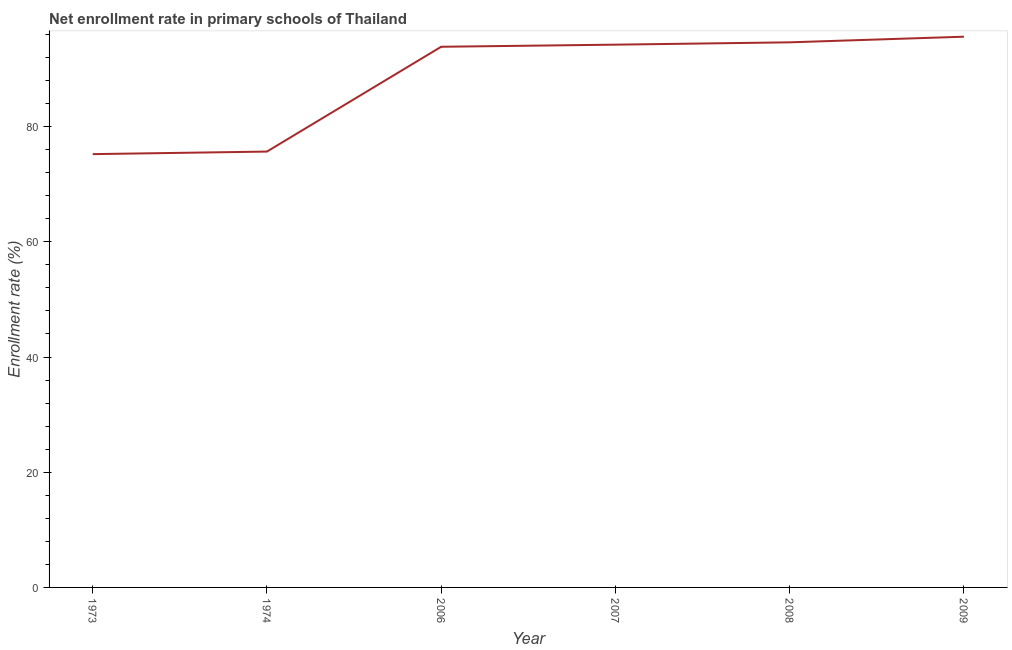What is the net enrollment rate in primary schools in 2009?
Provide a short and direct response. 95.61. Across all years, what is the maximum net enrollment rate in primary schools?
Give a very brief answer. 95.61. Across all years, what is the minimum net enrollment rate in primary schools?
Your answer should be very brief. 75.22. In which year was the net enrollment rate in primary schools minimum?
Your answer should be very brief. 1973. What is the sum of the net enrollment rate in primary schools?
Offer a very short reply. 529.22. What is the difference between the net enrollment rate in primary schools in 1974 and 2008?
Provide a succinct answer. -18.97. What is the average net enrollment rate in primary schools per year?
Your response must be concise. 88.2. What is the median net enrollment rate in primary schools?
Your response must be concise. 94.04. What is the ratio of the net enrollment rate in primary schools in 1973 to that in 2006?
Give a very brief answer. 0.8. What is the difference between the highest and the second highest net enrollment rate in primary schools?
Your response must be concise. 0.98. Is the sum of the net enrollment rate in primary schools in 2007 and 2008 greater than the maximum net enrollment rate in primary schools across all years?
Give a very brief answer. Yes. What is the difference between the highest and the lowest net enrollment rate in primary schools?
Make the answer very short. 20.39. How many years are there in the graph?
Your answer should be compact. 6. What is the difference between two consecutive major ticks on the Y-axis?
Make the answer very short. 20. Are the values on the major ticks of Y-axis written in scientific E-notation?
Offer a very short reply. No. Does the graph contain grids?
Ensure brevity in your answer.  No. What is the title of the graph?
Ensure brevity in your answer.  Net enrollment rate in primary schools of Thailand. What is the label or title of the X-axis?
Make the answer very short. Year. What is the label or title of the Y-axis?
Your answer should be compact. Enrollment rate (%). What is the Enrollment rate (%) of 1973?
Your answer should be very brief. 75.22. What is the Enrollment rate (%) in 1974?
Your response must be concise. 75.67. What is the Enrollment rate (%) of 2006?
Provide a short and direct response. 93.86. What is the Enrollment rate (%) of 2007?
Offer a very short reply. 94.23. What is the Enrollment rate (%) in 2008?
Make the answer very short. 94.63. What is the Enrollment rate (%) of 2009?
Your answer should be compact. 95.61. What is the difference between the Enrollment rate (%) in 1973 and 1974?
Your response must be concise. -0.44. What is the difference between the Enrollment rate (%) in 1973 and 2006?
Keep it short and to the point. -18.64. What is the difference between the Enrollment rate (%) in 1973 and 2007?
Give a very brief answer. -19. What is the difference between the Enrollment rate (%) in 1973 and 2008?
Provide a succinct answer. -19.41. What is the difference between the Enrollment rate (%) in 1973 and 2009?
Your response must be concise. -20.39. What is the difference between the Enrollment rate (%) in 1974 and 2006?
Offer a very short reply. -18.19. What is the difference between the Enrollment rate (%) in 1974 and 2007?
Make the answer very short. -18.56. What is the difference between the Enrollment rate (%) in 1974 and 2008?
Your answer should be very brief. -18.97. What is the difference between the Enrollment rate (%) in 1974 and 2009?
Your answer should be compact. -19.94. What is the difference between the Enrollment rate (%) in 2006 and 2007?
Provide a short and direct response. -0.37. What is the difference between the Enrollment rate (%) in 2006 and 2008?
Give a very brief answer. -0.77. What is the difference between the Enrollment rate (%) in 2006 and 2009?
Your response must be concise. -1.75. What is the difference between the Enrollment rate (%) in 2007 and 2008?
Your answer should be compact. -0.4. What is the difference between the Enrollment rate (%) in 2007 and 2009?
Your response must be concise. -1.38. What is the difference between the Enrollment rate (%) in 2008 and 2009?
Offer a very short reply. -0.98. What is the ratio of the Enrollment rate (%) in 1973 to that in 2006?
Offer a terse response. 0.8. What is the ratio of the Enrollment rate (%) in 1973 to that in 2007?
Your response must be concise. 0.8. What is the ratio of the Enrollment rate (%) in 1973 to that in 2008?
Offer a terse response. 0.8. What is the ratio of the Enrollment rate (%) in 1973 to that in 2009?
Your answer should be very brief. 0.79. What is the ratio of the Enrollment rate (%) in 1974 to that in 2006?
Your response must be concise. 0.81. What is the ratio of the Enrollment rate (%) in 1974 to that in 2007?
Keep it short and to the point. 0.8. What is the ratio of the Enrollment rate (%) in 1974 to that in 2008?
Offer a terse response. 0.8. What is the ratio of the Enrollment rate (%) in 1974 to that in 2009?
Offer a terse response. 0.79. What is the ratio of the Enrollment rate (%) in 2006 to that in 2007?
Keep it short and to the point. 1. What is the ratio of the Enrollment rate (%) in 2006 to that in 2009?
Your answer should be compact. 0.98. What is the ratio of the Enrollment rate (%) in 2008 to that in 2009?
Provide a short and direct response. 0.99. 